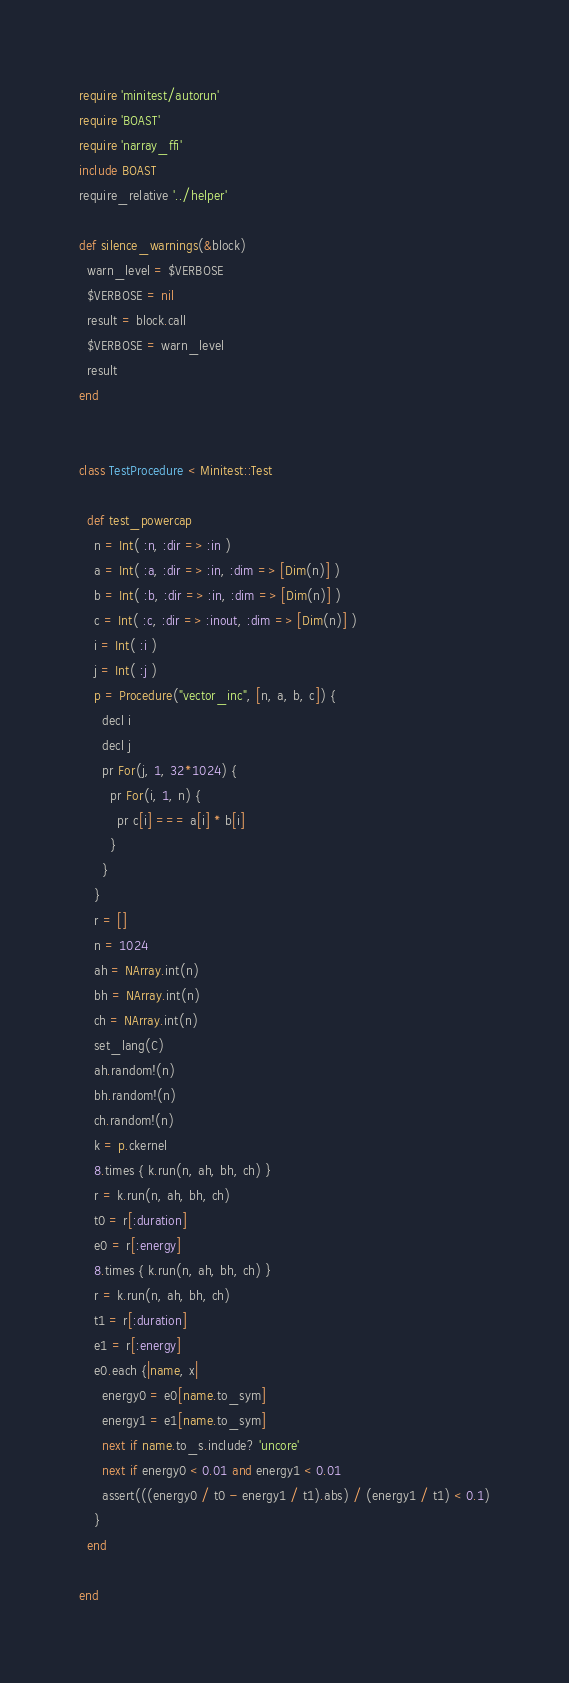<code> <loc_0><loc_0><loc_500><loc_500><_Ruby_>require 'minitest/autorun'
require 'BOAST'
require 'narray_ffi'
include BOAST
require_relative '../helper'

def silence_warnings(&block)
  warn_level = $VERBOSE
  $VERBOSE = nil
  result = block.call
  $VERBOSE = warn_level
  result
end


class TestProcedure < Minitest::Test

  def test_powercap
    n = Int( :n, :dir => :in )
    a = Int( :a, :dir => :in, :dim => [Dim(n)] )
    b = Int( :b, :dir => :in, :dim => [Dim(n)] )
    c = Int( :c, :dir => :inout, :dim => [Dim(n)] )
    i = Int( :i )
    j = Int( :j )
    p = Procedure("vector_inc", [n, a, b, c]) {
      decl i
      decl j
      pr For(j, 1, 32*1024) {
        pr For(i, 1, n) {
          pr c[i] === a[i] * b[i]
        }
      }
    }
    r = []
    n = 1024
    ah = NArray.int(n)
    bh = NArray.int(n)
    ch = NArray.int(n)
    set_lang(C)
    ah.random!(n)
    bh.random!(n)
    ch.random!(n)
    k = p.ckernel
    8.times { k.run(n, ah, bh, ch) }
    r = k.run(n, ah, bh, ch)
    t0 = r[:duration]
    e0 = r[:energy]
    8.times { k.run(n, ah, bh, ch) }
    r = k.run(n, ah, bh, ch)
    t1 = r[:duration]
    e1 = r[:energy]
    e0.each {|name, x|
      energy0 = e0[name.to_sym]
      energy1 = e1[name.to_sym]
      next if name.to_s.include? 'uncore'
      next if energy0 < 0.01 and energy1 < 0.01
      assert(((energy0 / t0 - energy1 / t1).abs) / (energy1 / t1) < 0.1)
    }
  end

end
</code> 